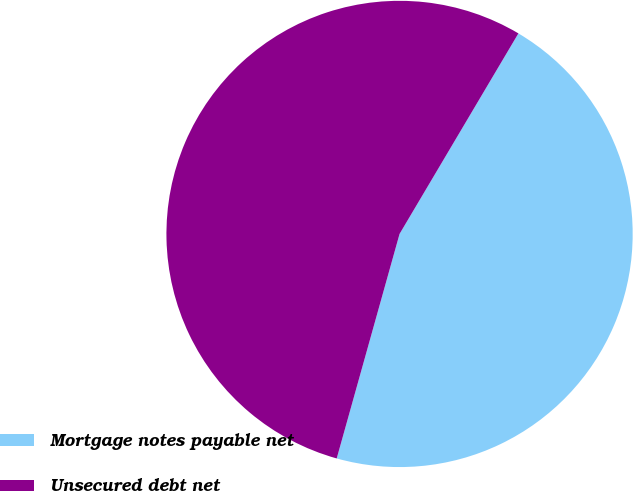Convert chart to OTSL. <chart><loc_0><loc_0><loc_500><loc_500><pie_chart><fcel>Mortgage notes payable net<fcel>Unsecured debt net<nl><fcel>45.83%<fcel>54.17%<nl></chart> 